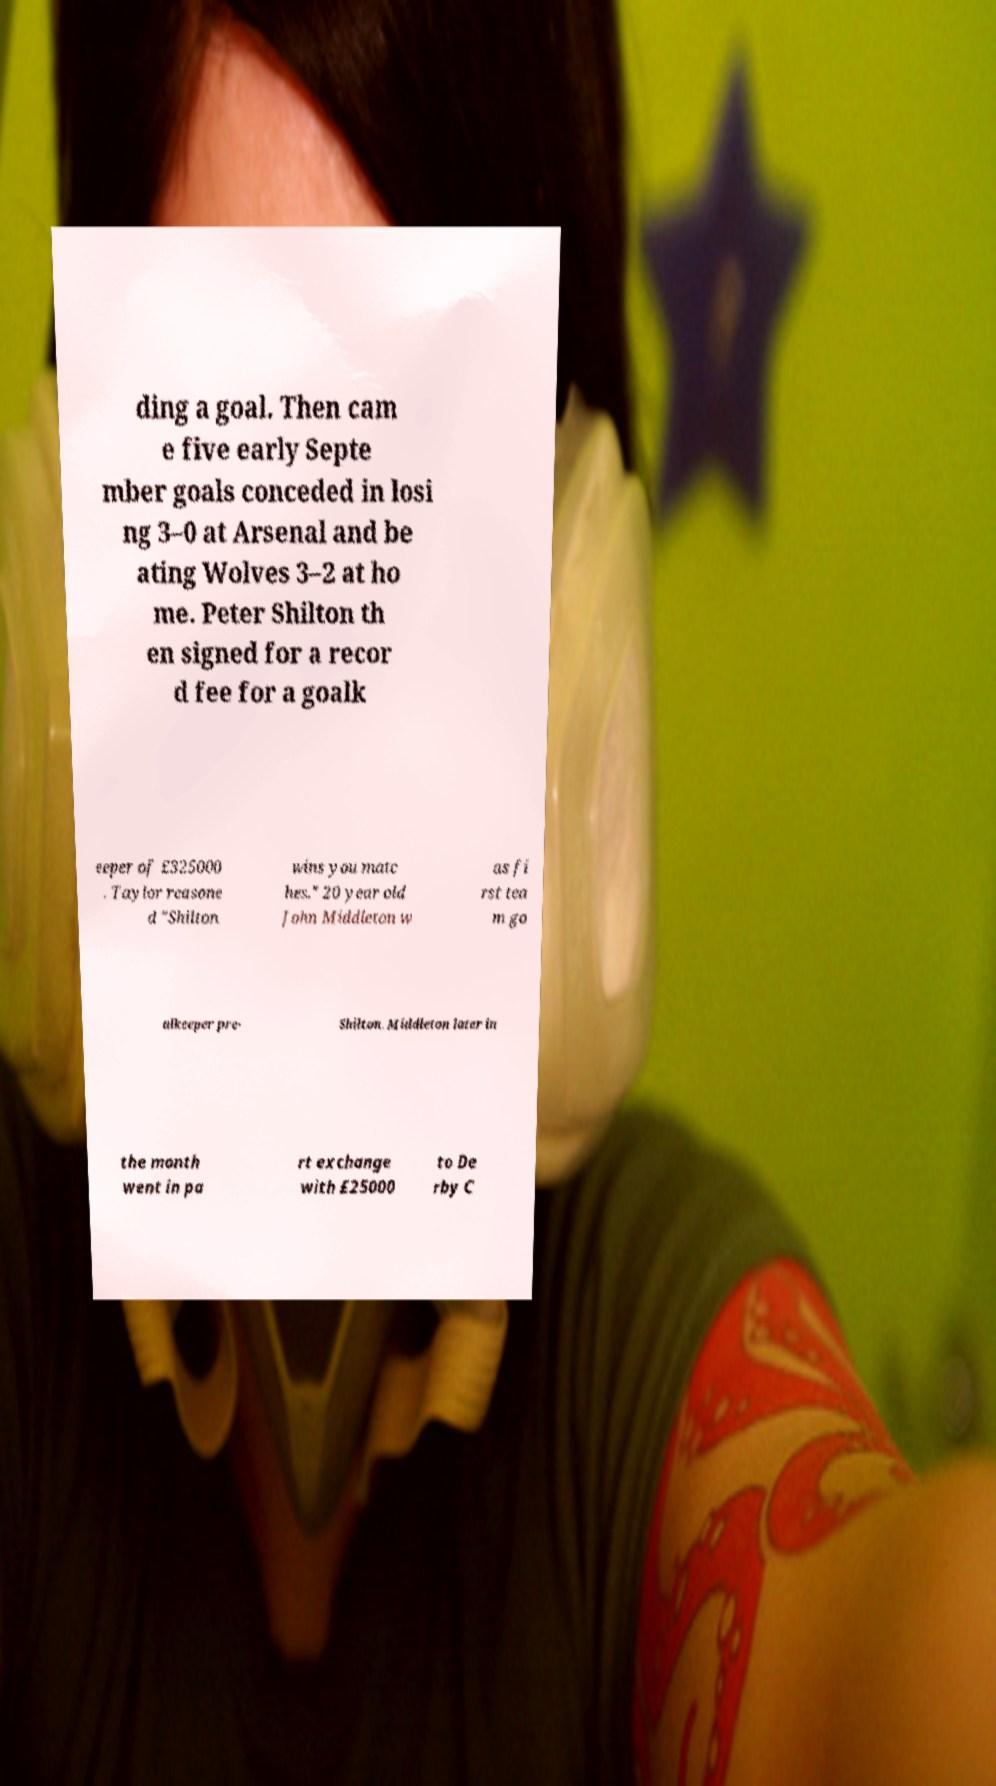There's text embedded in this image that I need extracted. Can you transcribe it verbatim? ding a goal. Then cam e five early Septe mber goals conceded in losi ng 3–0 at Arsenal and be ating Wolves 3–2 at ho me. Peter Shilton th en signed for a recor d fee for a goalk eeper of £325000 . Taylor reasone d "Shilton wins you matc hes." 20 year old John Middleton w as fi rst tea m go alkeeper pre- Shilton. Middleton later in the month went in pa rt exchange with £25000 to De rby C 